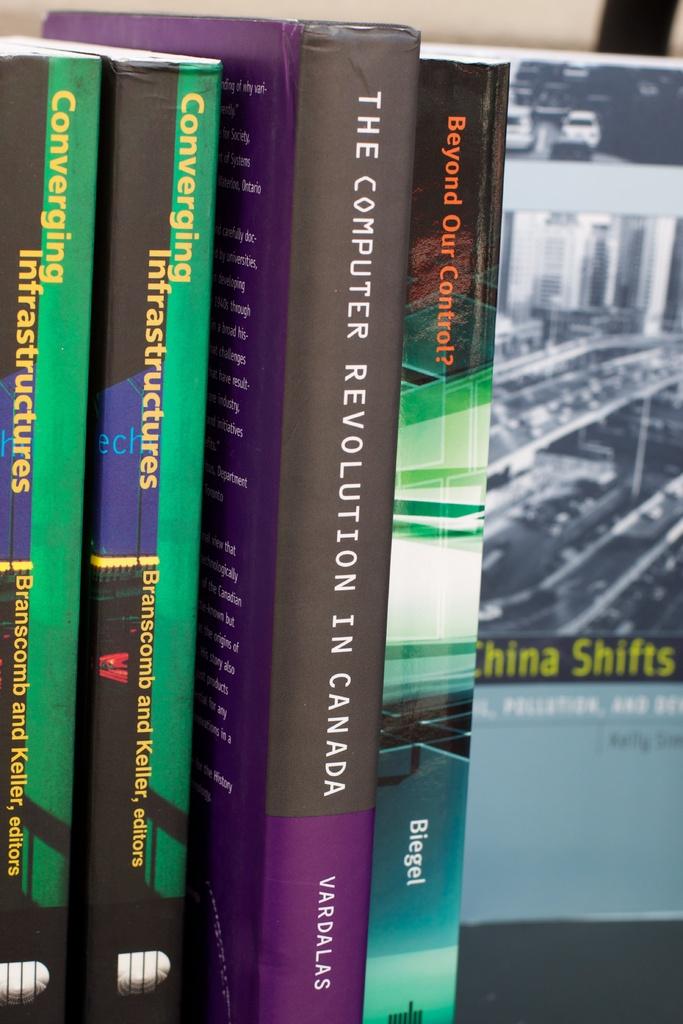Who wrote "the computer revolution in canada"?
Your answer should be compact. Vardalas. 